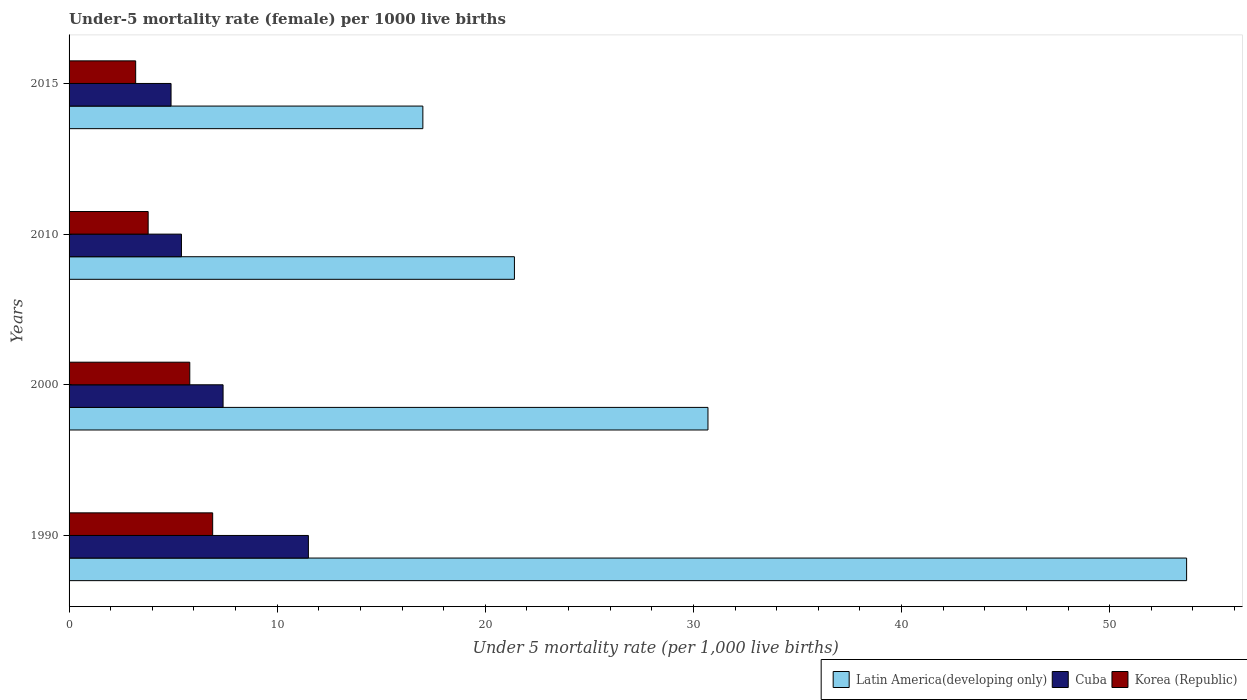How many groups of bars are there?
Your answer should be compact. 4. Are the number of bars per tick equal to the number of legend labels?
Make the answer very short. Yes. How many bars are there on the 1st tick from the top?
Make the answer very short. 3. How many bars are there on the 1st tick from the bottom?
Your answer should be compact. 3. What is the label of the 1st group of bars from the top?
Keep it short and to the point. 2015. In how many cases, is the number of bars for a given year not equal to the number of legend labels?
Provide a short and direct response. 0. What is the under-five mortality rate in Cuba in 2010?
Provide a succinct answer. 5.4. Across all years, what is the maximum under-five mortality rate in Latin America(developing only)?
Offer a terse response. 53.7. In which year was the under-five mortality rate in Latin America(developing only) minimum?
Give a very brief answer. 2015. What is the total under-five mortality rate in Korea (Republic) in the graph?
Provide a succinct answer. 19.7. What is the difference between the under-five mortality rate in Korea (Republic) in 2000 and that in 2015?
Make the answer very short. 2.6. What is the difference between the under-five mortality rate in Korea (Republic) in 2010 and the under-five mortality rate in Cuba in 2015?
Ensure brevity in your answer.  -1.1. What is the average under-five mortality rate in Korea (Republic) per year?
Provide a succinct answer. 4.92. In the year 2015, what is the difference between the under-five mortality rate in Latin America(developing only) and under-five mortality rate in Cuba?
Give a very brief answer. 12.1. What is the ratio of the under-five mortality rate in Korea (Republic) in 2000 to that in 2010?
Your answer should be compact. 1.53. What is the difference between the highest and the second highest under-five mortality rate in Latin America(developing only)?
Make the answer very short. 23. In how many years, is the under-five mortality rate in Latin America(developing only) greater than the average under-five mortality rate in Latin America(developing only) taken over all years?
Ensure brevity in your answer.  1. What does the 2nd bar from the top in 2000 represents?
Your answer should be compact. Cuba. What does the 2nd bar from the bottom in 2000 represents?
Ensure brevity in your answer.  Cuba. How many bars are there?
Your answer should be compact. 12. How many years are there in the graph?
Your answer should be compact. 4. What is the difference between two consecutive major ticks on the X-axis?
Ensure brevity in your answer.  10. Are the values on the major ticks of X-axis written in scientific E-notation?
Offer a very short reply. No. Does the graph contain any zero values?
Provide a short and direct response. No. Does the graph contain grids?
Offer a terse response. No. Where does the legend appear in the graph?
Keep it short and to the point. Bottom right. What is the title of the graph?
Ensure brevity in your answer.  Under-5 mortality rate (female) per 1000 live births. Does "Gabon" appear as one of the legend labels in the graph?
Provide a short and direct response. No. What is the label or title of the X-axis?
Offer a terse response. Under 5 mortality rate (per 1,0 live births). What is the Under 5 mortality rate (per 1,000 live births) of Latin America(developing only) in 1990?
Your answer should be compact. 53.7. What is the Under 5 mortality rate (per 1,000 live births) of Cuba in 1990?
Provide a succinct answer. 11.5. What is the Under 5 mortality rate (per 1,000 live births) of Latin America(developing only) in 2000?
Provide a short and direct response. 30.7. What is the Under 5 mortality rate (per 1,000 live births) of Cuba in 2000?
Keep it short and to the point. 7.4. What is the Under 5 mortality rate (per 1,000 live births) of Latin America(developing only) in 2010?
Your answer should be very brief. 21.4. What is the Under 5 mortality rate (per 1,000 live births) in Korea (Republic) in 2010?
Offer a very short reply. 3.8. What is the Under 5 mortality rate (per 1,000 live births) of Latin America(developing only) in 2015?
Make the answer very short. 17. What is the Under 5 mortality rate (per 1,000 live births) of Cuba in 2015?
Your answer should be compact. 4.9. What is the Under 5 mortality rate (per 1,000 live births) in Korea (Republic) in 2015?
Provide a succinct answer. 3.2. Across all years, what is the maximum Under 5 mortality rate (per 1,000 live births) of Latin America(developing only)?
Make the answer very short. 53.7. Across all years, what is the minimum Under 5 mortality rate (per 1,000 live births) in Cuba?
Offer a very short reply. 4.9. What is the total Under 5 mortality rate (per 1,000 live births) of Latin America(developing only) in the graph?
Provide a succinct answer. 122.8. What is the total Under 5 mortality rate (per 1,000 live births) in Cuba in the graph?
Ensure brevity in your answer.  29.2. What is the difference between the Under 5 mortality rate (per 1,000 live births) of Korea (Republic) in 1990 and that in 2000?
Offer a terse response. 1.1. What is the difference between the Under 5 mortality rate (per 1,000 live births) in Latin America(developing only) in 1990 and that in 2010?
Provide a short and direct response. 32.3. What is the difference between the Under 5 mortality rate (per 1,000 live births) of Korea (Republic) in 1990 and that in 2010?
Make the answer very short. 3.1. What is the difference between the Under 5 mortality rate (per 1,000 live births) in Latin America(developing only) in 1990 and that in 2015?
Your answer should be very brief. 36.7. What is the difference between the Under 5 mortality rate (per 1,000 live births) of Cuba in 1990 and that in 2015?
Ensure brevity in your answer.  6.6. What is the difference between the Under 5 mortality rate (per 1,000 live births) in Cuba in 2000 and that in 2010?
Your answer should be compact. 2. What is the difference between the Under 5 mortality rate (per 1,000 live births) of Korea (Republic) in 2000 and that in 2010?
Offer a very short reply. 2. What is the difference between the Under 5 mortality rate (per 1,000 live births) of Latin America(developing only) in 2000 and that in 2015?
Make the answer very short. 13.7. What is the difference between the Under 5 mortality rate (per 1,000 live births) in Cuba in 2000 and that in 2015?
Your answer should be very brief. 2.5. What is the difference between the Under 5 mortality rate (per 1,000 live births) in Korea (Republic) in 2000 and that in 2015?
Your response must be concise. 2.6. What is the difference between the Under 5 mortality rate (per 1,000 live births) of Latin America(developing only) in 1990 and the Under 5 mortality rate (per 1,000 live births) of Cuba in 2000?
Your answer should be very brief. 46.3. What is the difference between the Under 5 mortality rate (per 1,000 live births) of Latin America(developing only) in 1990 and the Under 5 mortality rate (per 1,000 live births) of Korea (Republic) in 2000?
Provide a succinct answer. 47.9. What is the difference between the Under 5 mortality rate (per 1,000 live births) in Latin America(developing only) in 1990 and the Under 5 mortality rate (per 1,000 live births) in Cuba in 2010?
Your answer should be very brief. 48.3. What is the difference between the Under 5 mortality rate (per 1,000 live births) in Latin America(developing only) in 1990 and the Under 5 mortality rate (per 1,000 live births) in Korea (Republic) in 2010?
Give a very brief answer. 49.9. What is the difference between the Under 5 mortality rate (per 1,000 live births) in Cuba in 1990 and the Under 5 mortality rate (per 1,000 live births) in Korea (Republic) in 2010?
Your answer should be very brief. 7.7. What is the difference between the Under 5 mortality rate (per 1,000 live births) in Latin America(developing only) in 1990 and the Under 5 mortality rate (per 1,000 live births) in Cuba in 2015?
Your answer should be very brief. 48.8. What is the difference between the Under 5 mortality rate (per 1,000 live births) in Latin America(developing only) in 1990 and the Under 5 mortality rate (per 1,000 live births) in Korea (Republic) in 2015?
Keep it short and to the point. 50.5. What is the difference between the Under 5 mortality rate (per 1,000 live births) of Latin America(developing only) in 2000 and the Under 5 mortality rate (per 1,000 live births) of Cuba in 2010?
Your response must be concise. 25.3. What is the difference between the Under 5 mortality rate (per 1,000 live births) of Latin America(developing only) in 2000 and the Under 5 mortality rate (per 1,000 live births) of Korea (Republic) in 2010?
Offer a terse response. 26.9. What is the difference between the Under 5 mortality rate (per 1,000 live births) in Latin America(developing only) in 2000 and the Under 5 mortality rate (per 1,000 live births) in Cuba in 2015?
Your response must be concise. 25.8. What is the difference between the Under 5 mortality rate (per 1,000 live births) of Latin America(developing only) in 2010 and the Under 5 mortality rate (per 1,000 live births) of Korea (Republic) in 2015?
Ensure brevity in your answer.  18.2. What is the difference between the Under 5 mortality rate (per 1,000 live births) of Cuba in 2010 and the Under 5 mortality rate (per 1,000 live births) of Korea (Republic) in 2015?
Provide a short and direct response. 2.2. What is the average Under 5 mortality rate (per 1,000 live births) in Latin America(developing only) per year?
Ensure brevity in your answer.  30.7. What is the average Under 5 mortality rate (per 1,000 live births) in Cuba per year?
Offer a terse response. 7.3. What is the average Under 5 mortality rate (per 1,000 live births) in Korea (Republic) per year?
Ensure brevity in your answer.  4.92. In the year 1990, what is the difference between the Under 5 mortality rate (per 1,000 live births) of Latin America(developing only) and Under 5 mortality rate (per 1,000 live births) of Cuba?
Make the answer very short. 42.2. In the year 1990, what is the difference between the Under 5 mortality rate (per 1,000 live births) of Latin America(developing only) and Under 5 mortality rate (per 1,000 live births) of Korea (Republic)?
Your answer should be very brief. 46.8. In the year 2000, what is the difference between the Under 5 mortality rate (per 1,000 live births) in Latin America(developing only) and Under 5 mortality rate (per 1,000 live births) in Cuba?
Provide a short and direct response. 23.3. In the year 2000, what is the difference between the Under 5 mortality rate (per 1,000 live births) of Latin America(developing only) and Under 5 mortality rate (per 1,000 live births) of Korea (Republic)?
Your response must be concise. 24.9. In the year 2010, what is the difference between the Under 5 mortality rate (per 1,000 live births) in Latin America(developing only) and Under 5 mortality rate (per 1,000 live births) in Korea (Republic)?
Ensure brevity in your answer.  17.6. What is the ratio of the Under 5 mortality rate (per 1,000 live births) of Latin America(developing only) in 1990 to that in 2000?
Offer a very short reply. 1.75. What is the ratio of the Under 5 mortality rate (per 1,000 live births) in Cuba in 1990 to that in 2000?
Ensure brevity in your answer.  1.55. What is the ratio of the Under 5 mortality rate (per 1,000 live births) of Korea (Republic) in 1990 to that in 2000?
Give a very brief answer. 1.19. What is the ratio of the Under 5 mortality rate (per 1,000 live births) in Latin America(developing only) in 1990 to that in 2010?
Your answer should be compact. 2.51. What is the ratio of the Under 5 mortality rate (per 1,000 live births) of Cuba in 1990 to that in 2010?
Your response must be concise. 2.13. What is the ratio of the Under 5 mortality rate (per 1,000 live births) in Korea (Republic) in 1990 to that in 2010?
Keep it short and to the point. 1.82. What is the ratio of the Under 5 mortality rate (per 1,000 live births) in Latin America(developing only) in 1990 to that in 2015?
Provide a short and direct response. 3.16. What is the ratio of the Under 5 mortality rate (per 1,000 live births) in Cuba in 1990 to that in 2015?
Your response must be concise. 2.35. What is the ratio of the Under 5 mortality rate (per 1,000 live births) in Korea (Republic) in 1990 to that in 2015?
Your answer should be very brief. 2.16. What is the ratio of the Under 5 mortality rate (per 1,000 live births) of Latin America(developing only) in 2000 to that in 2010?
Give a very brief answer. 1.43. What is the ratio of the Under 5 mortality rate (per 1,000 live births) in Cuba in 2000 to that in 2010?
Keep it short and to the point. 1.37. What is the ratio of the Under 5 mortality rate (per 1,000 live births) in Korea (Republic) in 2000 to that in 2010?
Make the answer very short. 1.53. What is the ratio of the Under 5 mortality rate (per 1,000 live births) in Latin America(developing only) in 2000 to that in 2015?
Your response must be concise. 1.81. What is the ratio of the Under 5 mortality rate (per 1,000 live births) of Cuba in 2000 to that in 2015?
Your answer should be very brief. 1.51. What is the ratio of the Under 5 mortality rate (per 1,000 live births) of Korea (Republic) in 2000 to that in 2015?
Provide a succinct answer. 1.81. What is the ratio of the Under 5 mortality rate (per 1,000 live births) of Latin America(developing only) in 2010 to that in 2015?
Your answer should be compact. 1.26. What is the ratio of the Under 5 mortality rate (per 1,000 live births) of Cuba in 2010 to that in 2015?
Keep it short and to the point. 1.1. What is the ratio of the Under 5 mortality rate (per 1,000 live births) in Korea (Republic) in 2010 to that in 2015?
Keep it short and to the point. 1.19. What is the difference between the highest and the second highest Under 5 mortality rate (per 1,000 live births) in Latin America(developing only)?
Make the answer very short. 23. What is the difference between the highest and the second highest Under 5 mortality rate (per 1,000 live births) of Korea (Republic)?
Keep it short and to the point. 1.1. What is the difference between the highest and the lowest Under 5 mortality rate (per 1,000 live births) in Latin America(developing only)?
Your answer should be compact. 36.7. What is the difference between the highest and the lowest Under 5 mortality rate (per 1,000 live births) of Cuba?
Your response must be concise. 6.6. 